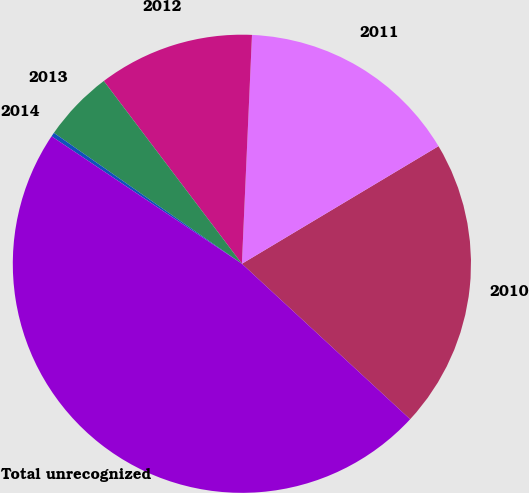Convert chart to OTSL. <chart><loc_0><loc_0><loc_500><loc_500><pie_chart><fcel>2010<fcel>2011<fcel>2012<fcel>2013<fcel>2014<fcel>Total unrecognized<nl><fcel>20.45%<fcel>15.72%<fcel>11.0%<fcel>5.02%<fcel>0.29%<fcel>47.52%<nl></chart> 